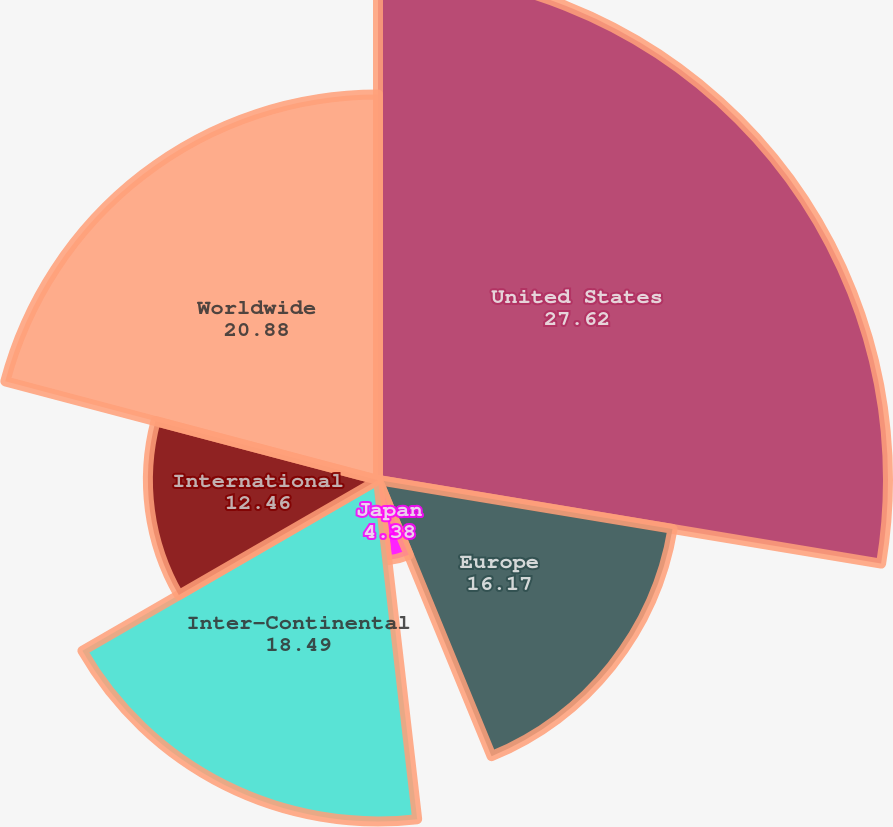Convert chart. <chart><loc_0><loc_0><loc_500><loc_500><pie_chart><fcel>United States<fcel>Europe<fcel>Japan<fcel>Inter-Continental<fcel>International<fcel>Worldwide<nl><fcel>27.62%<fcel>16.17%<fcel>4.38%<fcel>18.49%<fcel>12.46%<fcel>20.88%<nl></chart> 